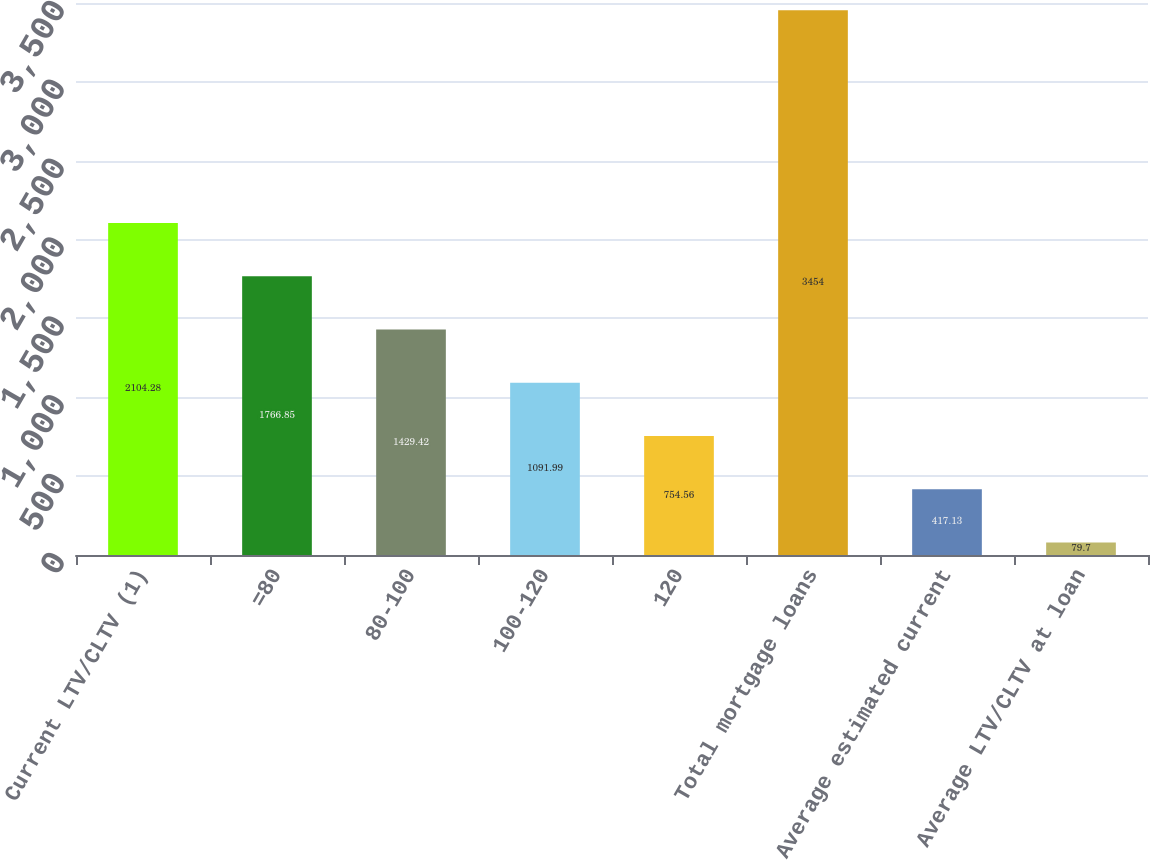Convert chart to OTSL. <chart><loc_0><loc_0><loc_500><loc_500><bar_chart><fcel>Current LTV/CLTV (1)<fcel>=80<fcel>80-100<fcel>100-120<fcel>120<fcel>Total mortgage loans<fcel>Average estimated current<fcel>Average LTV/CLTV at loan<nl><fcel>2104.28<fcel>1766.85<fcel>1429.42<fcel>1091.99<fcel>754.56<fcel>3454<fcel>417.13<fcel>79.7<nl></chart> 